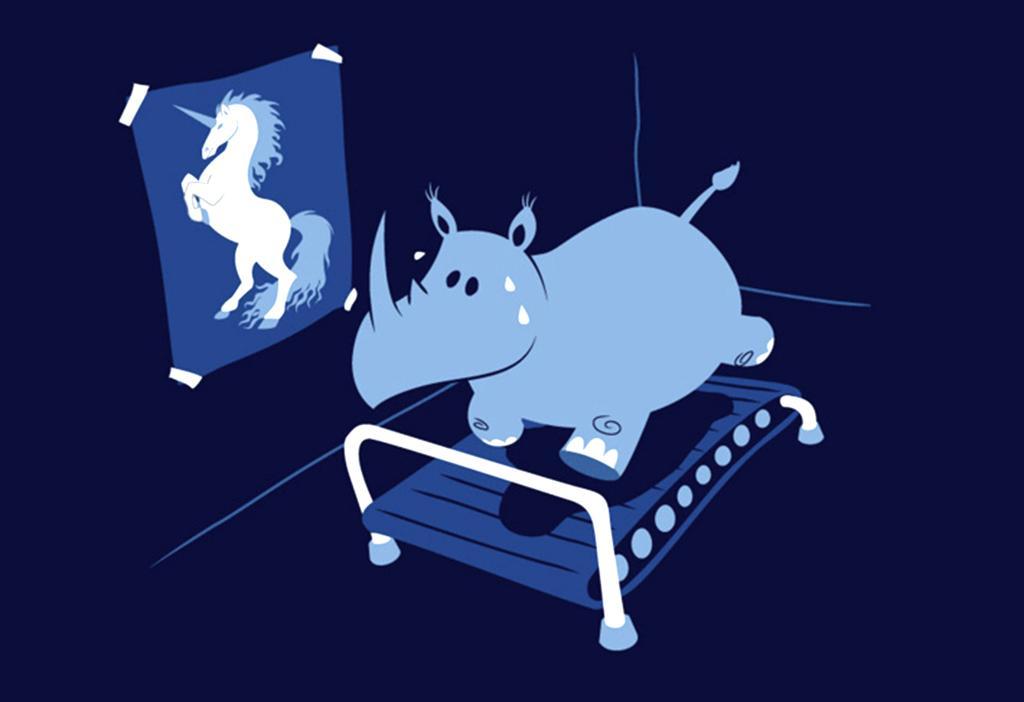Please provide a concise description of this image. This image looks like an animated image, in which I can see a bed, animal, poster of a horse and a colored background. 